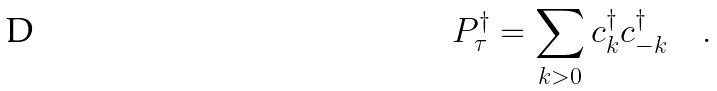<formula> <loc_0><loc_0><loc_500><loc_500>P ^ { \dagger } _ { \tau } = \sum _ { k > 0 } c ^ { \dagger } _ { k } c ^ { \dagger } _ { - k } \quad .</formula> 